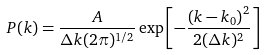Convert formula to latex. <formula><loc_0><loc_0><loc_500><loc_500>P ( k ) = \frac { A } { \Delta k ( 2 \pi ) ^ { 1 / 2 } } \exp \left [ - \frac { \left ( k - k _ { 0 } \right ) ^ { 2 } } { 2 ( \Delta k ) ^ { 2 } } \right ]</formula> 